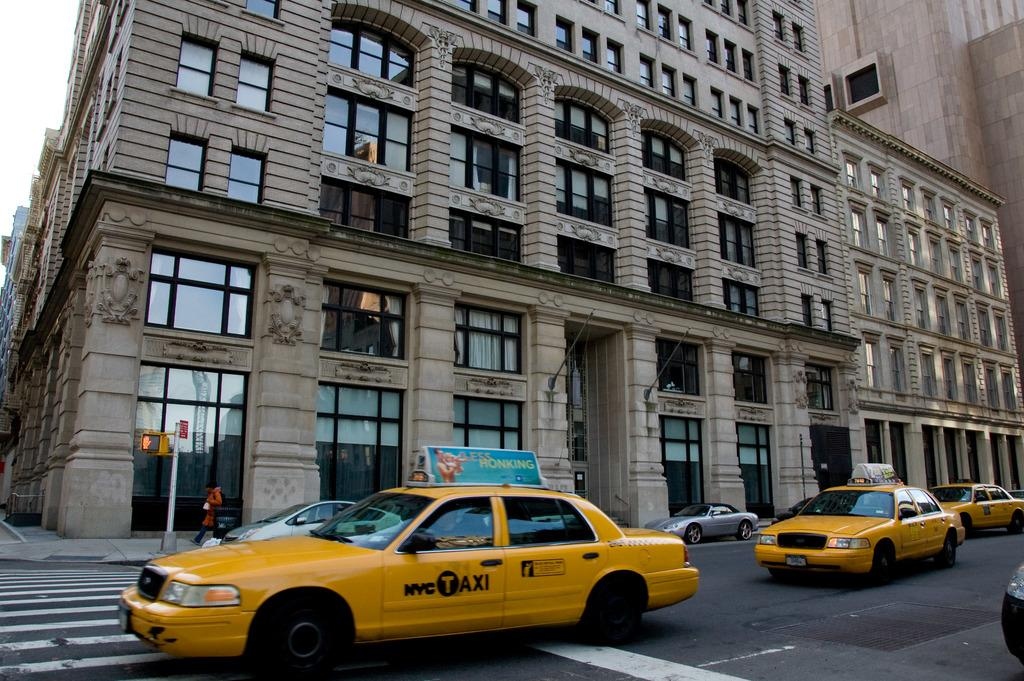<image>
Offer a succinct explanation of the picture presented. A NYC Taxi with a sign that says Less Honking on top of it. 